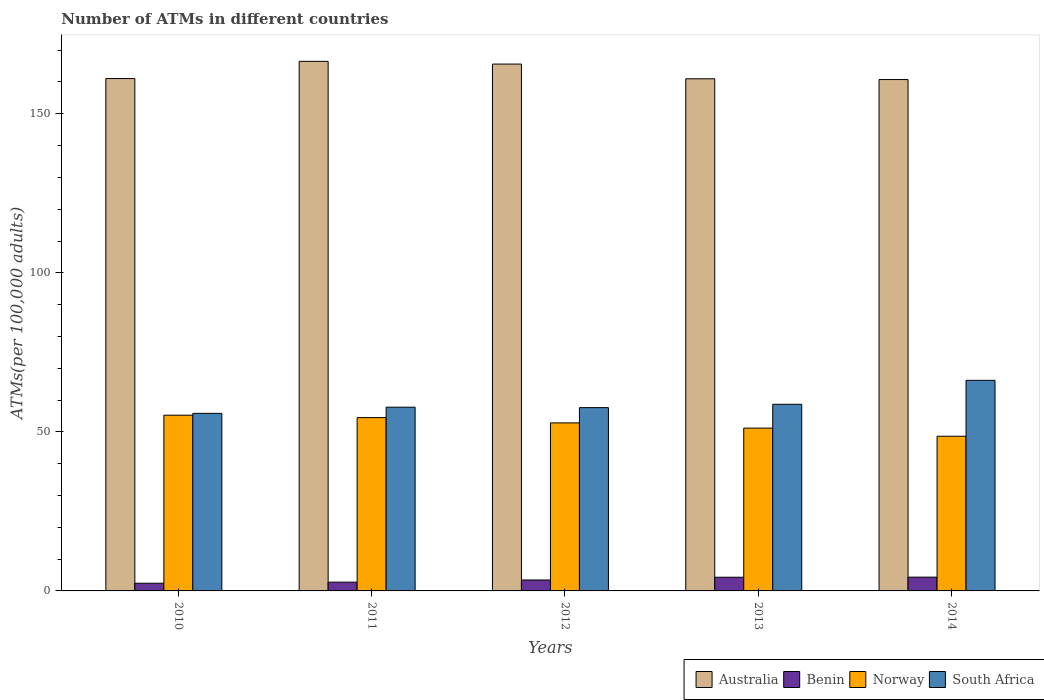How many different coloured bars are there?
Give a very brief answer. 4. How many groups of bars are there?
Offer a terse response. 5. Are the number of bars on each tick of the X-axis equal?
Provide a short and direct response. Yes. How many bars are there on the 5th tick from the right?
Offer a very short reply. 4. What is the label of the 2nd group of bars from the left?
Offer a terse response. 2011. What is the number of ATMs in Norway in 2014?
Provide a short and direct response. 48.62. Across all years, what is the maximum number of ATMs in Norway?
Your answer should be compact. 55.24. Across all years, what is the minimum number of ATMs in Norway?
Offer a terse response. 48.62. In which year was the number of ATMs in Australia minimum?
Offer a very short reply. 2014. What is the total number of ATMs in Australia in the graph?
Give a very brief answer. 814.91. What is the difference between the number of ATMs in Norway in 2010 and that in 2012?
Your answer should be compact. 2.42. What is the difference between the number of ATMs in South Africa in 2012 and the number of ATMs in Benin in 2013?
Make the answer very short. 53.32. What is the average number of ATMs in Australia per year?
Provide a short and direct response. 162.98. In the year 2013, what is the difference between the number of ATMs in Benin and number of ATMs in Norway?
Your answer should be compact. -46.88. In how many years, is the number of ATMs in Australia greater than 70?
Offer a very short reply. 5. What is the ratio of the number of ATMs in Norway in 2013 to that in 2014?
Ensure brevity in your answer.  1.05. What is the difference between the highest and the second highest number of ATMs in Benin?
Provide a short and direct response. 0.03. What is the difference between the highest and the lowest number of ATMs in Benin?
Your answer should be very brief. 1.91. Is the sum of the number of ATMs in Australia in 2010 and 2012 greater than the maximum number of ATMs in Benin across all years?
Your answer should be very brief. Yes. Is it the case that in every year, the sum of the number of ATMs in South Africa and number of ATMs in Australia is greater than the sum of number of ATMs in Norway and number of ATMs in Benin?
Offer a terse response. Yes. What does the 3rd bar from the left in 2014 represents?
Provide a succinct answer. Norway. What does the 3rd bar from the right in 2014 represents?
Offer a terse response. Benin. Are all the bars in the graph horizontal?
Offer a very short reply. No. How many years are there in the graph?
Your answer should be compact. 5. Does the graph contain any zero values?
Give a very brief answer. No. How are the legend labels stacked?
Your answer should be very brief. Horizontal. What is the title of the graph?
Provide a succinct answer. Number of ATMs in different countries. What is the label or title of the Y-axis?
Provide a short and direct response. ATMs(per 100,0 adults). What is the ATMs(per 100,000 adults) in Australia in 2010?
Your answer should be very brief. 161.07. What is the ATMs(per 100,000 adults) in Benin in 2010?
Provide a short and direct response. 2.42. What is the ATMs(per 100,000 adults) in Norway in 2010?
Provide a succinct answer. 55.24. What is the ATMs(per 100,000 adults) of South Africa in 2010?
Offer a terse response. 55.81. What is the ATMs(per 100,000 adults) of Australia in 2011?
Your response must be concise. 166.47. What is the ATMs(per 100,000 adults) of Benin in 2011?
Make the answer very short. 2.75. What is the ATMs(per 100,000 adults) in Norway in 2011?
Offer a very short reply. 54.49. What is the ATMs(per 100,000 adults) of South Africa in 2011?
Keep it short and to the point. 57.76. What is the ATMs(per 100,000 adults) of Australia in 2012?
Offer a very short reply. 165.62. What is the ATMs(per 100,000 adults) in Benin in 2012?
Offer a terse response. 3.44. What is the ATMs(per 100,000 adults) of Norway in 2012?
Keep it short and to the point. 52.83. What is the ATMs(per 100,000 adults) in South Africa in 2012?
Provide a succinct answer. 57.62. What is the ATMs(per 100,000 adults) in Australia in 2013?
Your answer should be very brief. 160.99. What is the ATMs(per 100,000 adults) of Benin in 2013?
Your answer should be very brief. 4.3. What is the ATMs(per 100,000 adults) in Norway in 2013?
Provide a short and direct response. 51.18. What is the ATMs(per 100,000 adults) of South Africa in 2013?
Your response must be concise. 58.67. What is the ATMs(per 100,000 adults) in Australia in 2014?
Make the answer very short. 160.75. What is the ATMs(per 100,000 adults) in Benin in 2014?
Provide a short and direct response. 4.33. What is the ATMs(per 100,000 adults) in Norway in 2014?
Ensure brevity in your answer.  48.62. What is the ATMs(per 100,000 adults) of South Africa in 2014?
Your answer should be very brief. 66.2. Across all years, what is the maximum ATMs(per 100,000 adults) of Australia?
Offer a terse response. 166.47. Across all years, what is the maximum ATMs(per 100,000 adults) of Benin?
Give a very brief answer. 4.33. Across all years, what is the maximum ATMs(per 100,000 adults) in Norway?
Offer a very short reply. 55.24. Across all years, what is the maximum ATMs(per 100,000 adults) of South Africa?
Give a very brief answer. 66.2. Across all years, what is the minimum ATMs(per 100,000 adults) of Australia?
Your answer should be compact. 160.75. Across all years, what is the minimum ATMs(per 100,000 adults) of Benin?
Provide a short and direct response. 2.42. Across all years, what is the minimum ATMs(per 100,000 adults) of Norway?
Ensure brevity in your answer.  48.62. Across all years, what is the minimum ATMs(per 100,000 adults) in South Africa?
Provide a succinct answer. 55.81. What is the total ATMs(per 100,000 adults) in Australia in the graph?
Provide a short and direct response. 814.91. What is the total ATMs(per 100,000 adults) in Benin in the graph?
Provide a succinct answer. 17.23. What is the total ATMs(per 100,000 adults) in Norway in the graph?
Ensure brevity in your answer.  262.36. What is the total ATMs(per 100,000 adults) of South Africa in the graph?
Your response must be concise. 296.06. What is the difference between the ATMs(per 100,000 adults) in Australia in 2010 and that in 2011?
Make the answer very short. -5.41. What is the difference between the ATMs(per 100,000 adults) of Benin in 2010 and that in 2011?
Give a very brief answer. -0.34. What is the difference between the ATMs(per 100,000 adults) of Norway in 2010 and that in 2011?
Provide a short and direct response. 0.75. What is the difference between the ATMs(per 100,000 adults) of South Africa in 2010 and that in 2011?
Offer a very short reply. -1.94. What is the difference between the ATMs(per 100,000 adults) in Australia in 2010 and that in 2012?
Ensure brevity in your answer.  -4.55. What is the difference between the ATMs(per 100,000 adults) in Benin in 2010 and that in 2012?
Your answer should be compact. -1.02. What is the difference between the ATMs(per 100,000 adults) of Norway in 2010 and that in 2012?
Offer a terse response. 2.42. What is the difference between the ATMs(per 100,000 adults) of South Africa in 2010 and that in 2012?
Offer a terse response. -1.81. What is the difference between the ATMs(per 100,000 adults) of Australia in 2010 and that in 2013?
Provide a short and direct response. 0.07. What is the difference between the ATMs(per 100,000 adults) in Benin in 2010 and that in 2013?
Keep it short and to the point. -1.88. What is the difference between the ATMs(per 100,000 adults) in Norway in 2010 and that in 2013?
Keep it short and to the point. 4.06. What is the difference between the ATMs(per 100,000 adults) in South Africa in 2010 and that in 2013?
Offer a terse response. -2.85. What is the difference between the ATMs(per 100,000 adults) in Australia in 2010 and that in 2014?
Make the answer very short. 0.32. What is the difference between the ATMs(per 100,000 adults) in Benin in 2010 and that in 2014?
Provide a succinct answer. -1.91. What is the difference between the ATMs(per 100,000 adults) in Norway in 2010 and that in 2014?
Provide a short and direct response. 6.62. What is the difference between the ATMs(per 100,000 adults) in South Africa in 2010 and that in 2014?
Provide a succinct answer. -10.38. What is the difference between the ATMs(per 100,000 adults) in Australia in 2011 and that in 2012?
Keep it short and to the point. 0.85. What is the difference between the ATMs(per 100,000 adults) in Benin in 2011 and that in 2012?
Keep it short and to the point. -0.68. What is the difference between the ATMs(per 100,000 adults) of Norway in 2011 and that in 2012?
Offer a very short reply. 1.66. What is the difference between the ATMs(per 100,000 adults) in South Africa in 2011 and that in 2012?
Your answer should be very brief. 0.14. What is the difference between the ATMs(per 100,000 adults) in Australia in 2011 and that in 2013?
Keep it short and to the point. 5.48. What is the difference between the ATMs(per 100,000 adults) in Benin in 2011 and that in 2013?
Give a very brief answer. -1.54. What is the difference between the ATMs(per 100,000 adults) of Norway in 2011 and that in 2013?
Make the answer very short. 3.31. What is the difference between the ATMs(per 100,000 adults) in South Africa in 2011 and that in 2013?
Keep it short and to the point. -0.91. What is the difference between the ATMs(per 100,000 adults) of Australia in 2011 and that in 2014?
Offer a terse response. 5.72. What is the difference between the ATMs(per 100,000 adults) of Benin in 2011 and that in 2014?
Offer a terse response. -1.58. What is the difference between the ATMs(per 100,000 adults) in Norway in 2011 and that in 2014?
Ensure brevity in your answer.  5.86. What is the difference between the ATMs(per 100,000 adults) in South Africa in 2011 and that in 2014?
Give a very brief answer. -8.44. What is the difference between the ATMs(per 100,000 adults) of Australia in 2012 and that in 2013?
Provide a succinct answer. 4.63. What is the difference between the ATMs(per 100,000 adults) of Benin in 2012 and that in 2013?
Ensure brevity in your answer.  -0.86. What is the difference between the ATMs(per 100,000 adults) in Norway in 2012 and that in 2013?
Offer a terse response. 1.65. What is the difference between the ATMs(per 100,000 adults) in South Africa in 2012 and that in 2013?
Your response must be concise. -1.05. What is the difference between the ATMs(per 100,000 adults) in Australia in 2012 and that in 2014?
Your response must be concise. 4.87. What is the difference between the ATMs(per 100,000 adults) in Benin in 2012 and that in 2014?
Ensure brevity in your answer.  -0.89. What is the difference between the ATMs(per 100,000 adults) in Norway in 2012 and that in 2014?
Provide a succinct answer. 4.2. What is the difference between the ATMs(per 100,000 adults) of South Africa in 2012 and that in 2014?
Make the answer very short. -8.58. What is the difference between the ATMs(per 100,000 adults) of Australia in 2013 and that in 2014?
Your response must be concise. 0.24. What is the difference between the ATMs(per 100,000 adults) in Benin in 2013 and that in 2014?
Keep it short and to the point. -0.03. What is the difference between the ATMs(per 100,000 adults) of Norway in 2013 and that in 2014?
Make the answer very short. 2.56. What is the difference between the ATMs(per 100,000 adults) of South Africa in 2013 and that in 2014?
Give a very brief answer. -7.53. What is the difference between the ATMs(per 100,000 adults) in Australia in 2010 and the ATMs(per 100,000 adults) in Benin in 2011?
Provide a succinct answer. 158.31. What is the difference between the ATMs(per 100,000 adults) of Australia in 2010 and the ATMs(per 100,000 adults) of Norway in 2011?
Offer a very short reply. 106.58. What is the difference between the ATMs(per 100,000 adults) of Australia in 2010 and the ATMs(per 100,000 adults) of South Africa in 2011?
Offer a terse response. 103.31. What is the difference between the ATMs(per 100,000 adults) in Benin in 2010 and the ATMs(per 100,000 adults) in Norway in 2011?
Your answer should be very brief. -52.07. What is the difference between the ATMs(per 100,000 adults) in Benin in 2010 and the ATMs(per 100,000 adults) in South Africa in 2011?
Give a very brief answer. -55.34. What is the difference between the ATMs(per 100,000 adults) in Norway in 2010 and the ATMs(per 100,000 adults) in South Africa in 2011?
Offer a very short reply. -2.52. What is the difference between the ATMs(per 100,000 adults) in Australia in 2010 and the ATMs(per 100,000 adults) in Benin in 2012?
Provide a succinct answer. 157.63. What is the difference between the ATMs(per 100,000 adults) of Australia in 2010 and the ATMs(per 100,000 adults) of Norway in 2012?
Offer a very short reply. 108.24. What is the difference between the ATMs(per 100,000 adults) in Australia in 2010 and the ATMs(per 100,000 adults) in South Africa in 2012?
Ensure brevity in your answer.  103.45. What is the difference between the ATMs(per 100,000 adults) in Benin in 2010 and the ATMs(per 100,000 adults) in Norway in 2012?
Offer a very short reply. -50.41. What is the difference between the ATMs(per 100,000 adults) in Benin in 2010 and the ATMs(per 100,000 adults) in South Africa in 2012?
Make the answer very short. -55.21. What is the difference between the ATMs(per 100,000 adults) of Norway in 2010 and the ATMs(per 100,000 adults) of South Africa in 2012?
Offer a terse response. -2.38. What is the difference between the ATMs(per 100,000 adults) of Australia in 2010 and the ATMs(per 100,000 adults) of Benin in 2013?
Provide a succinct answer. 156.77. What is the difference between the ATMs(per 100,000 adults) of Australia in 2010 and the ATMs(per 100,000 adults) of Norway in 2013?
Your answer should be very brief. 109.89. What is the difference between the ATMs(per 100,000 adults) in Australia in 2010 and the ATMs(per 100,000 adults) in South Africa in 2013?
Your response must be concise. 102.4. What is the difference between the ATMs(per 100,000 adults) in Benin in 2010 and the ATMs(per 100,000 adults) in Norway in 2013?
Offer a terse response. -48.76. What is the difference between the ATMs(per 100,000 adults) in Benin in 2010 and the ATMs(per 100,000 adults) in South Africa in 2013?
Your response must be concise. -56.25. What is the difference between the ATMs(per 100,000 adults) in Norway in 2010 and the ATMs(per 100,000 adults) in South Africa in 2013?
Ensure brevity in your answer.  -3.43. What is the difference between the ATMs(per 100,000 adults) in Australia in 2010 and the ATMs(per 100,000 adults) in Benin in 2014?
Your answer should be very brief. 156.74. What is the difference between the ATMs(per 100,000 adults) in Australia in 2010 and the ATMs(per 100,000 adults) in Norway in 2014?
Your answer should be very brief. 112.45. What is the difference between the ATMs(per 100,000 adults) of Australia in 2010 and the ATMs(per 100,000 adults) of South Africa in 2014?
Your answer should be compact. 94.87. What is the difference between the ATMs(per 100,000 adults) of Benin in 2010 and the ATMs(per 100,000 adults) of Norway in 2014?
Provide a short and direct response. -46.21. What is the difference between the ATMs(per 100,000 adults) in Benin in 2010 and the ATMs(per 100,000 adults) in South Africa in 2014?
Provide a short and direct response. -63.78. What is the difference between the ATMs(per 100,000 adults) in Norway in 2010 and the ATMs(per 100,000 adults) in South Africa in 2014?
Offer a terse response. -10.96. What is the difference between the ATMs(per 100,000 adults) of Australia in 2011 and the ATMs(per 100,000 adults) of Benin in 2012?
Give a very brief answer. 163.04. What is the difference between the ATMs(per 100,000 adults) in Australia in 2011 and the ATMs(per 100,000 adults) in Norway in 2012?
Provide a succinct answer. 113.65. What is the difference between the ATMs(per 100,000 adults) in Australia in 2011 and the ATMs(per 100,000 adults) in South Africa in 2012?
Your answer should be very brief. 108.85. What is the difference between the ATMs(per 100,000 adults) of Benin in 2011 and the ATMs(per 100,000 adults) of Norway in 2012?
Offer a very short reply. -50.07. What is the difference between the ATMs(per 100,000 adults) in Benin in 2011 and the ATMs(per 100,000 adults) in South Africa in 2012?
Your answer should be compact. -54.87. What is the difference between the ATMs(per 100,000 adults) in Norway in 2011 and the ATMs(per 100,000 adults) in South Africa in 2012?
Your response must be concise. -3.13. What is the difference between the ATMs(per 100,000 adults) in Australia in 2011 and the ATMs(per 100,000 adults) in Benin in 2013?
Provide a short and direct response. 162.18. What is the difference between the ATMs(per 100,000 adults) of Australia in 2011 and the ATMs(per 100,000 adults) of Norway in 2013?
Your answer should be compact. 115.29. What is the difference between the ATMs(per 100,000 adults) of Australia in 2011 and the ATMs(per 100,000 adults) of South Africa in 2013?
Keep it short and to the point. 107.81. What is the difference between the ATMs(per 100,000 adults) in Benin in 2011 and the ATMs(per 100,000 adults) in Norway in 2013?
Offer a very short reply. -48.43. What is the difference between the ATMs(per 100,000 adults) of Benin in 2011 and the ATMs(per 100,000 adults) of South Africa in 2013?
Your response must be concise. -55.91. What is the difference between the ATMs(per 100,000 adults) of Norway in 2011 and the ATMs(per 100,000 adults) of South Africa in 2013?
Your answer should be compact. -4.18. What is the difference between the ATMs(per 100,000 adults) of Australia in 2011 and the ATMs(per 100,000 adults) of Benin in 2014?
Provide a short and direct response. 162.14. What is the difference between the ATMs(per 100,000 adults) of Australia in 2011 and the ATMs(per 100,000 adults) of Norway in 2014?
Keep it short and to the point. 117.85. What is the difference between the ATMs(per 100,000 adults) of Australia in 2011 and the ATMs(per 100,000 adults) of South Africa in 2014?
Provide a short and direct response. 100.28. What is the difference between the ATMs(per 100,000 adults) of Benin in 2011 and the ATMs(per 100,000 adults) of Norway in 2014?
Your answer should be very brief. -45.87. What is the difference between the ATMs(per 100,000 adults) of Benin in 2011 and the ATMs(per 100,000 adults) of South Africa in 2014?
Make the answer very short. -63.44. What is the difference between the ATMs(per 100,000 adults) of Norway in 2011 and the ATMs(per 100,000 adults) of South Africa in 2014?
Ensure brevity in your answer.  -11.71. What is the difference between the ATMs(per 100,000 adults) of Australia in 2012 and the ATMs(per 100,000 adults) of Benin in 2013?
Give a very brief answer. 161.32. What is the difference between the ATMs(per 100,000 adults) in Australia in 2012 and the ATMs(per 100,000 adults) in Norway in 2013?
Ensure brevity in your answer.  114.44. What is the difference between the ATMs(per 100,000 adults) of Australia in 2012 and the ATMs(per 100,000 adults) of South Africa in 2013?
Provide a short and direct response. 106.95. What is the difference between the ATMs(per 100,000 adults) of Benin in 2012 and the ATMs(per 100,000 adults) of Norway in 2013?
Make the answer very short. -47.74. What is the difference between the ATMs(per 100,000 adults) of Benin in 2012 and the ATMs(per 100,000 adults) of South Africa in 2013?
Make the answer very short. -55.23. What is the difference between the ATMs(per 100,000 adults) in Norway in 2012 and the ATMs(per 100,000 adults) in South Africa in 2013?
Offer a terse response. -5.84. What is the difference between the ATMs(per 100,000 adults) of Australia in 2012 and the ATMs(per 100,000 adults) of Benin in 2014?
Give a very brief answer. 161.29. What is the difference between the ATMs(per 100,000 adults) of Australia in 2012 and the ATMs(per 100,000 adults) of Norway in 2014?
Keep it short and to the point. 117. What is the difference between the ATMs(per 100,000 adults) in Australia in 2012 and the ATMs(per 100,000 adults) in South Africa in 2014?
Provide a short and direct response. 99.42. What is the difference between the ATMs(per 100,000 adults) in Benin in 2012 and the ATMs(per 100,000 adults) in Norway in 2014?
Provide a short and direct response. -45.19. What is the difference between the ATMs(per 100,000 adults) of Benin in 2012 and the ATMs(per 100,000 adults) of South Africa in 2014?
Ensure brevity in your answer.  -62.76. What is the difference between the ATMs(per 100,000 adults) in Norway in 2012 and the ATMs(per 100,000 adults) in South Africa in 2014?
Offer a terse response. -13.37. What is the difference between the ATMs(per 100,000 adults) in Australia in 2013 and the ATMs(per 100,000 adults) in Benin in 2014?
Your answer should be very brief. 156.67. What is the difference between the ATMs(per 100,000 adults) in Australia in 2013 and the ATMs(per 100,000 adults) in Norway in 2014?
Your answer should be very brief. 112.37. What is the difference between the ATMs(per 100,000 adults) of Australia in 2013 and the ATMs(per 100,000 adults) of South Africa in 2014?
Ensure brevity in your answer.  94.8. What is the difference between the ATMs(per 100,000 adults) of Benin in 2013 and the ATMs(per 100,000 adults) of Norway in 2014?
Offer a terse response. -44.32. What is the difference between the ATMs(per 100,000 adults) of Benin in 2013 and the ATMs(per 100,000 adults) of South Africa in 2014?
Your response must be concise. -61.9. What is the difference between the ATMs(per 100,000 adults) in Norway in 2013 and the ATMs(per 100,000 adults) in South Africa in 2014?
Your answer should be compact. -15.02. What is the average ATMs(per 100,000 adults) of Australia per year?
Your response must be concise. 162.98. What is the average ATMs(per 100,000 adults) in Benin per year?
Provide a succinct answer. 3.45. What is the average ATMs(per 100,000 adults) in Norway per year?
Offer a terse response. 52.47. What is the average ATMs(per 100,000 adults) in South Africa per year?
Give a very brief answer. 59.21. In the year 2010, what is the difference between the ATMs(per 100,000 adults) of Australia and ATMs(per 100,000 adults) of Benin?
Provide a succinct answer. 158.65. In the year 2010, what is the difference between the ATMs(per 100,000 adults) in Australia and ATMs(per 100,000 adults) in Norway?
Provide a short and direct response. 105.83. In the year 2010, what is the difference between the ATMs(per 100,000 adults) in Australia and ATMs(per 100,000 adults) in South Africa?
Give a very brief answer. 105.26. In the year 2010, what is the difference between the ATMs(per 100,000 adults) of Benin and ATMs(per 100,000 adults) of Norway?
Your response must be concise. -52.82. In the year 2010, what is the difference between the ATMs(per 100,000 adults) in Benin and ATMs(per 100,000 adults) in South Africa?
Your answer should be very brief. -53.4. In the year 2010, what is the difference between the ATMs(per 100,000 adults) in Norway and ATMs(per 100,000 adults) in South Africa?
Offer a terse response. -0.57. In the year 2011, what is the difference between the ATMs(per 100,000 adults) of Australia and ATMs(per 100,000 adults) of Benin?
Offer a terse response. 163.72. In the year 2011, what is the difference between the ATMs(per 100,000 adults) of Australia and ATMs(per 100,000 adults) of Norway?
Offer a terse response. 111.99. In the year 2011, what is the difference between the ATMs(per 100,000 adults) of Australia and ATMs(per 100,000 adults) of South Africa?
Offer a terse response. 108.72. In the year 2011, what is the difference between the ATMs(per 100,000 adults) of Benin and ATMs(per 100,000 adults) of Norway?
Your response must be concise. -51.73. In the year 2011, what is the difference between the ATMs(per 100,000 adults) in Benin and ATMs(per 100,000 adults) in South Africa?
Your answer should be compact. -55. In the year 2011, what is the difference between the ATMs(per 100,000 adults) of Norway and ATMs(per 100,000 adults) of South Africa?
Your answer should be very brief. -3.27. In the year 2012, what is the difference between the ATMs(per 100,000 adults) of Australia and ATMs(per 100,000 adults) of Benin?
Provide a succinct answer. 162.19. In the year 2012, what is the difference between the ATMs(per 100,000 adults) in Australia and ATMs(per 100,000 adults) in Norway?
Ensure brevity in your answer.  112.8. In the year 2012, what is the difference between the ATMs(per 100,000 adults) of Australia and ATMs(per 100,000 adults) of South Africa?
Make the answer very short. 108. In the year 2012, what is the difference between the ATMs(per 100,000 adults) in Benin and ATMs(per 100,000 adults) in Norway?
Give a very brief answer. -49.39. In the year 2012, what is the difference between the ATMs(per 100,000 adults) of Benin and ATMs(per 100,000 adults) of South Africa?
Offer a terse response. -54.19. In the year 2012, what is the difference between the ATMs(per 100,000 adults) in Norway and ATMs(per 100,000 adults) in South Africa?
Ensure brevity in your answer.  -4.8. In the year 2013, what is the difference between the ATMs(per 100,000 adults) in Australia and ATMs(per 100,000 adults) in Benin?
Provide a short and direct response. 156.7. In the year 2013, what is the difference between the ATMs(per 100,000 adults) in Australia and ATMs(per 100,000 adults) in Norway?
Your answer should be compact. 109.81. In the year 2013, what is the difference between the ATMs(per 100,000 adults) in Australia and ATMs(per 100,000 adults) in South Africa?
Ensure brevity in your answer.  102.33. In the year 2013, what is the difference between the ATMs(per 100,000 adults) in Benin and ATMs(per 100,000 adults) in Norway?
Ensure brevity in your answer.  -46.88. In the year 2013, what is the difference between the ATMs(per 100,000 adults) of Benin and ATMs(per 100,000 adults) of South Africa?
Ensure brevity in your answer.  -54.37. In the year 2013, what is the difference between the ATMs(per 100,000 adults) in Norway and ATMs(per 100,000 adults) in South Africa?
Provide a short and direct response. -7.49. In the year 2014, what is the difference between the ATMs(per 100,000 adults) in Australia and ATMs(per 100,000 adults) in Benin?
Keep it short and to the point. 156.42. In the year 2014, what is the difference between the ATMs(per 100,000 adults) of Australia and ATMs(per 100,000 adults) of Norway?
Your answer should be very brief. 112.13. In the year 2014, what is the difference between the ATMs(per 100,000 adults) in Australia and ATMs(per 100,000 adults) in South Africa?
Keep it short and to the point. 94.55. In the year 2014, what is the difference between the ATMs(per 100,000 adults) of Benin and ATMs(per 100,000 adults) of Norway?
Ensure brevity in your answer.  -44.29. In the year 2014, what is the difference between the ATMs(per 100,000 adults) in Benin and ATMs(per 100,000 adults) in South Africa?
Provide a succinct answer. -61.87. In the year 2014, what is the difference between the ATMs(per 100,000 adults) in Norway and ATMs(per 100,000 adults) in South Africa?
Your response must be concise. -17.58. What is the ratio of the ATMs(per 100,000 adults) in Australia in 2010 to that in 2011?
Your answer should be very brief. 0.97. What is the ratio of the ATMs(per 100,000 adults) in Benin in 2010 to that in 2011?
Make the answer very short. 0.88. What is the ratio of the ATMs(per 100,000 adults) in Norway in 2010 to that in 2011?
Your response must be concise. 1.01. What is the ratio of the ATMs(per 100,000 adults) in South Africa in 2010 to that in 2011?
Provide a short and direct response. 0.97. What is the ratio of the ATMs(per 100,000 adults) in Australia in 2010 to that in 2012?
Offer a very short reply. 0.97. What is the ratio of the ATMs(per 100,000 adults) of Benin in 2010 to that in 2012?
Make the answer very short. 0.7. What is the ratio of the ATMs(per 100,000 adults) of Norway in 2010 to that in 2012?
Your answer should be compact. 1.05. What is the ratio of the ATMs(per 100,000 adults) of South Africa in 2010 to that in 2012?
Your answer should be very brief. 0.97. What is the ratio of the ATMs(per 100,000 adults) in Benin in 2010 to that in 2013?
Offer a very short reply. 0.56. What is the ratio of the ATMs(per 100,000 adults) in Norway in 2010 to that in 2013?
Ensure brevity in your answer.  1.08. What is the ratio of the ATMs(per 100,000 adults) in South Africa in 2010 to that in 2013?
Give a very brief answer. 0.95. What is the ratio of the ATMs(per 100,000 adults) in Australia in 2010 to that in 2014?
Your answer should be very brief. 1. What is the ratio of the ATMs(per 100,000 adults) in Benin in 2010 to that in 2014?
Keep it short and to the point. 0.56. What is the ratio of the ATMs(per 100,000 adults) in Norway in 2010 to that in 2014?
Offer a very short reply. 1.14. What is the ratio of the ATMs(per 100,000 adults) of South Africa in 2010 to that in 2014?
Your answer should be compact. 0.84. What is the ratio of the ATMs(per 100,000 adults) in Australia in 2011 to that in 2012?
Keep it short and to the point. 1.01. What is the ratio of the ATMs(per 100,000 adults) in Benin in 2011 to that in 2012?
Ensure brevity in your answer.  0.8. What is the ratio of the ATMs(per 100,000 adults) in Norway in 2011 to that in 2012?
Your answer should be compact. 1.03. What is the ratio of the ATMs(per 100,000 adults) of South Africa in 2011 to that in 2012?
Make the answer very short. 1. What is the ratio of the ATMs(per 100,000 adults) in Australia in 2011 to that in 2013?
Make the answer very short. 1.03. What is the ratio of the ATMs(per 100,000 adults) of Benin in 2011 to that in 2013?
Ensure brevity in your answer.  0.64. What is the ratio of the ATMs(per 100,000 adults) in Norway in 2011 to that in 2013?
Ensure brevity in your answer.  1.06. What is the ratio of the ATMs(per 100,000 adults) in South Africa in 2011 to that in 2013?
Offer a terse response. 0.98. What is the ratio of the ATMs(per 100,000 adults) of Australia in 2011 to that in 2014?
Your answer should be very brief. 1.04. What is the ratio of the ATMs(per 100,000 adults) of Benin in 2011 to that in 2014?
Keep it short and to the point. 0.64. What is the ratio of the ATMs(per 100,000 adults) in Norway in 2011 to that in 2014?
Give a very brief answer. 1.12. What is the ratio of the ATMs(per 100,000 adults) in South Africa in 2011 to that in 2014?
Give a very brief answer. 0.87. What is the ratio of the ATMs(per 100,000 adults) in Australia in 2012 to that in 2013?
Your response must be concise. 1.03. What is the ratio of the ATMs(per 100,000 adults) of Benin in 2012 to that in 2013?
Provide a short and direct response. 0.8. What is the ratio of the ATMs(per 100,000 adults) of Norway in 2012 to that in 2013?
Provide a succinct answer. 1.03. What is the ratio of the ATMs(per 100,000 adults) of South Africa in 2012 to that in 2013?
Offer a terse response. 0.98. What is the ratio of the ATMs(per 100,000 adults) of Australia in 2012 to that in 2014?
Make the answer very short. 1.03. What is the ratio of the ATMs(per 100,000 adults) of Benin in 2012 to that in 2014?
Offer a very short reply. 0.79. What is the ratio of the ATMs(per 100,000 adults) in Norway in 2012 to that in 2014?
Make the answer very short. 1.09. What is the ratio of the ATMs(per 100,000 adults) in South Africa in 2012 to that in 2014?
Keep it short and to the point. 0.87. What is the ratio of the ATMs(per 100,000 adults) in Norway in 2013 to that in 2014?
Give a very brief answer. 1.05. What is the ratio of the ATMs(per 100,000 adults) of South Africa in 2013 to that in 2014?
Keep it short and to the point. 0.89. What is the difference between the highest and the second highest ATMs(per 100,000 adults) of Australia?
Ensure brevity in your answer.  0.85. What is the difference between the highest and the second highest ATMs(per 100,000 adults) of Benin?
Offer a terse response. 0.03. What is the difference between the highest and the second highest ATMs(per 100,000 adults) in Norway?
Your answer should be compact. 0.75. What is the difference between the highest and the second highest ATMs(per 100,000 adults) in South Africa?
Ensure brevity in your answer.  7.53. What is the difference between the highest and the lowest ATMs(per 100,000 adults) in Australia?
Offer a very short reply. 5.72. What is the difference between the highest and the lowest ATMs(per 100,000 adults) of Benin?
Give a very brief answer. 1.91. What is the difference between the highest and the lowest ATMs(per 100,000 adults) of Norway?
Provide a short and direct response. 6.62. What is the difference between the highest and the lowest ATMs(per 100,000 adults) in South Africa?
Your answer should be compact. 10.38. 